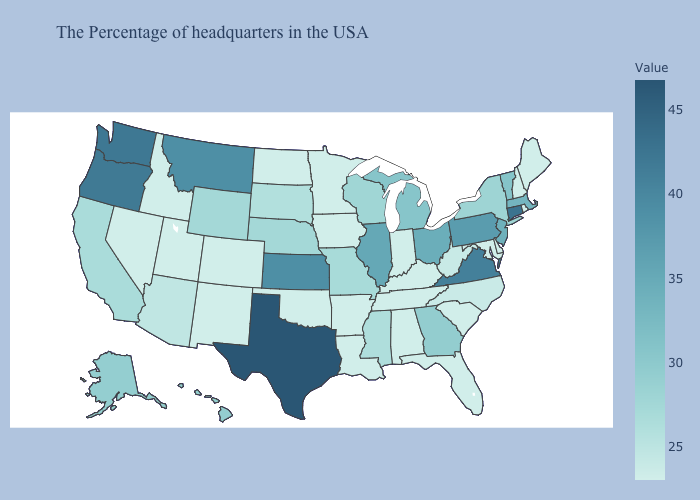Does Kansas have the highest value in the MidWest?
Short answer required. Yes. Among the states that border West Virginia , does Virginia have the lowest value?
Give a very brief answer. No. Does Ohio have the lowest value in the USA?
Quick response, please. No. Which states have the lowest value in the USA?
Answer briefly. Maine, Rhode Island, New Hampshire, Delaware, Maryland, South Carolina, Florida, Kentucky, Indiana, Alabama, Tennessee, Louisiana, Arkansas, Minnesota, Iowa, Oklahoma, North Dakota, Colorado, New Mexico, Utah, Idaho, Nevada. Does the map have missing data?
Give a very brief answer. No. Which states hav the highest value in the Northeast?
Short answer required. Connecticut. 